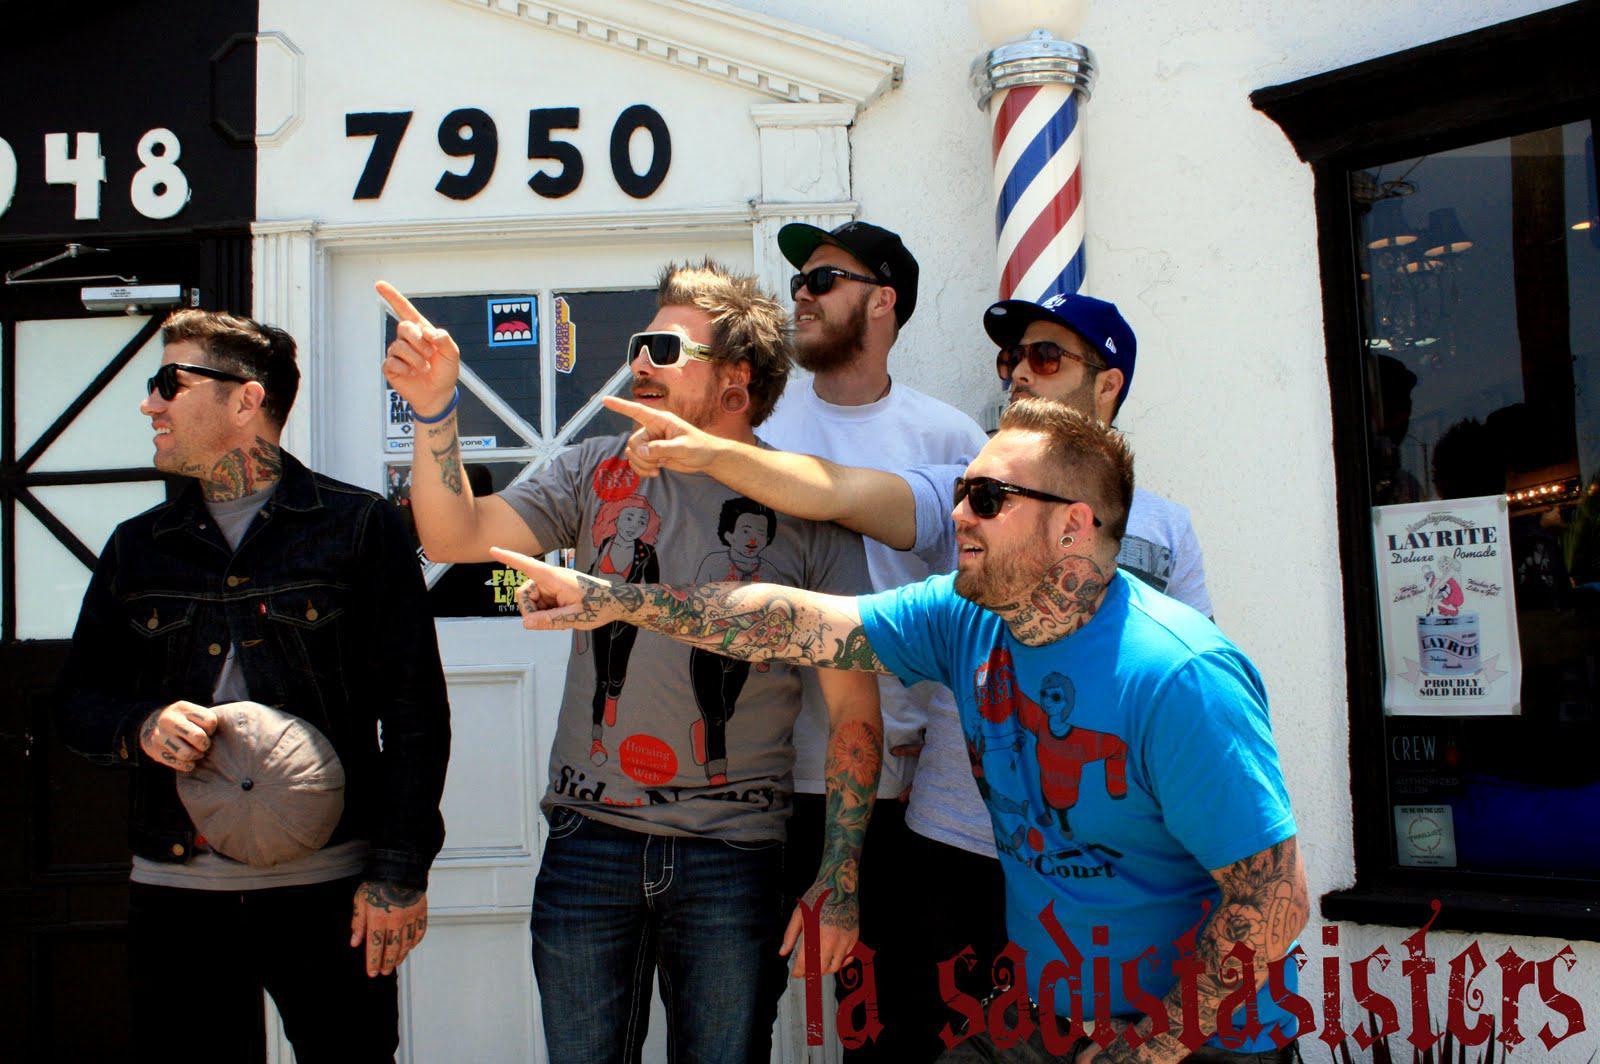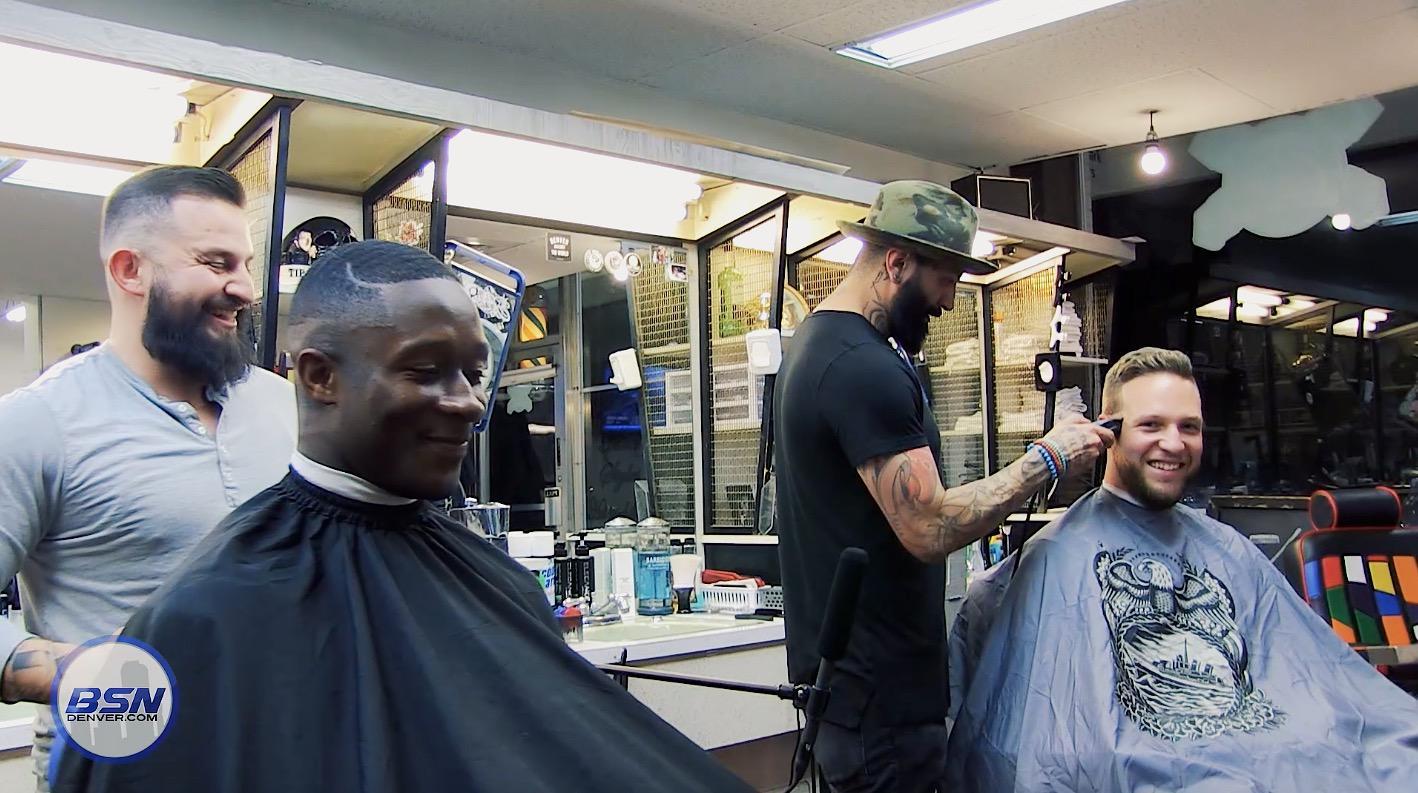The first image is the image on the left, the second image is the image on the right. Given the left and right images, does the statement "Someone is wearing a hat in both images." hold true? Answer yes or no. Yes. The first image is the image on the left, the second image is the image on the right. Analyze the images presented: Is the assertion "IN at least one image there are two men in a row getting their cut." valid? Answer yes or no. Yes. 